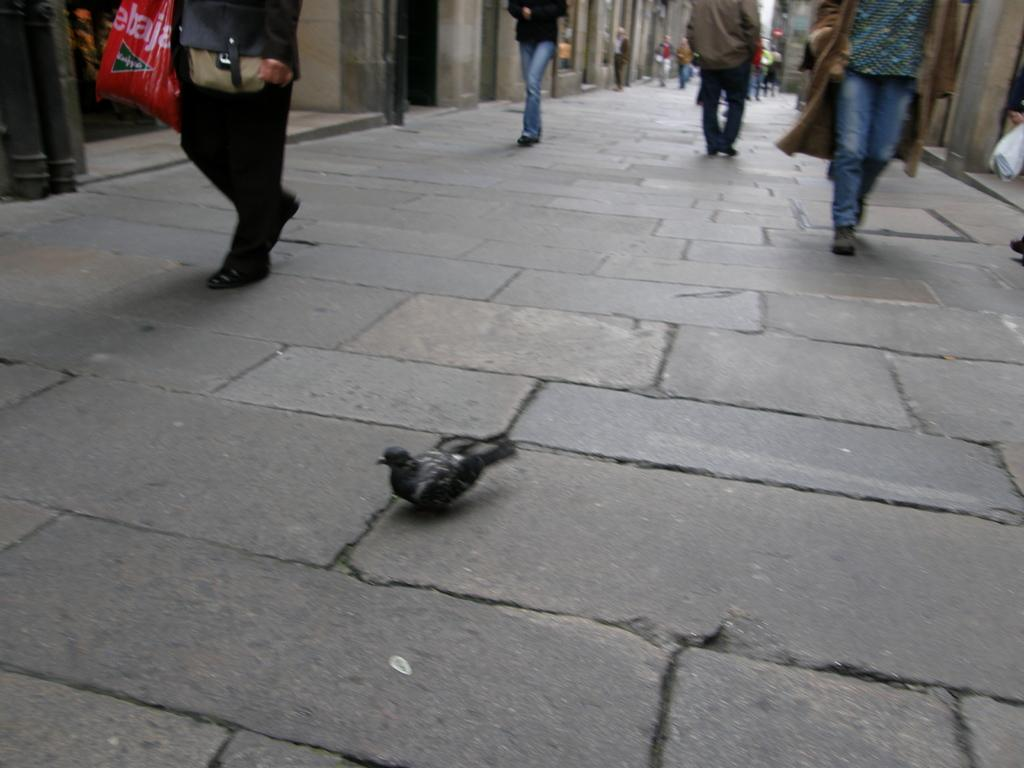What are the people in the image doing? The people in the image are walking on the road. What type of animal can be seen in the image? There is a bird in the image. What can be seen on both sides of the road in the image? There are buildings on the left side and the right side of the image. What women's theory is being discussed in the image? There is no discussion or mention of any theory in the image, and there are no women specifically mentioned. 